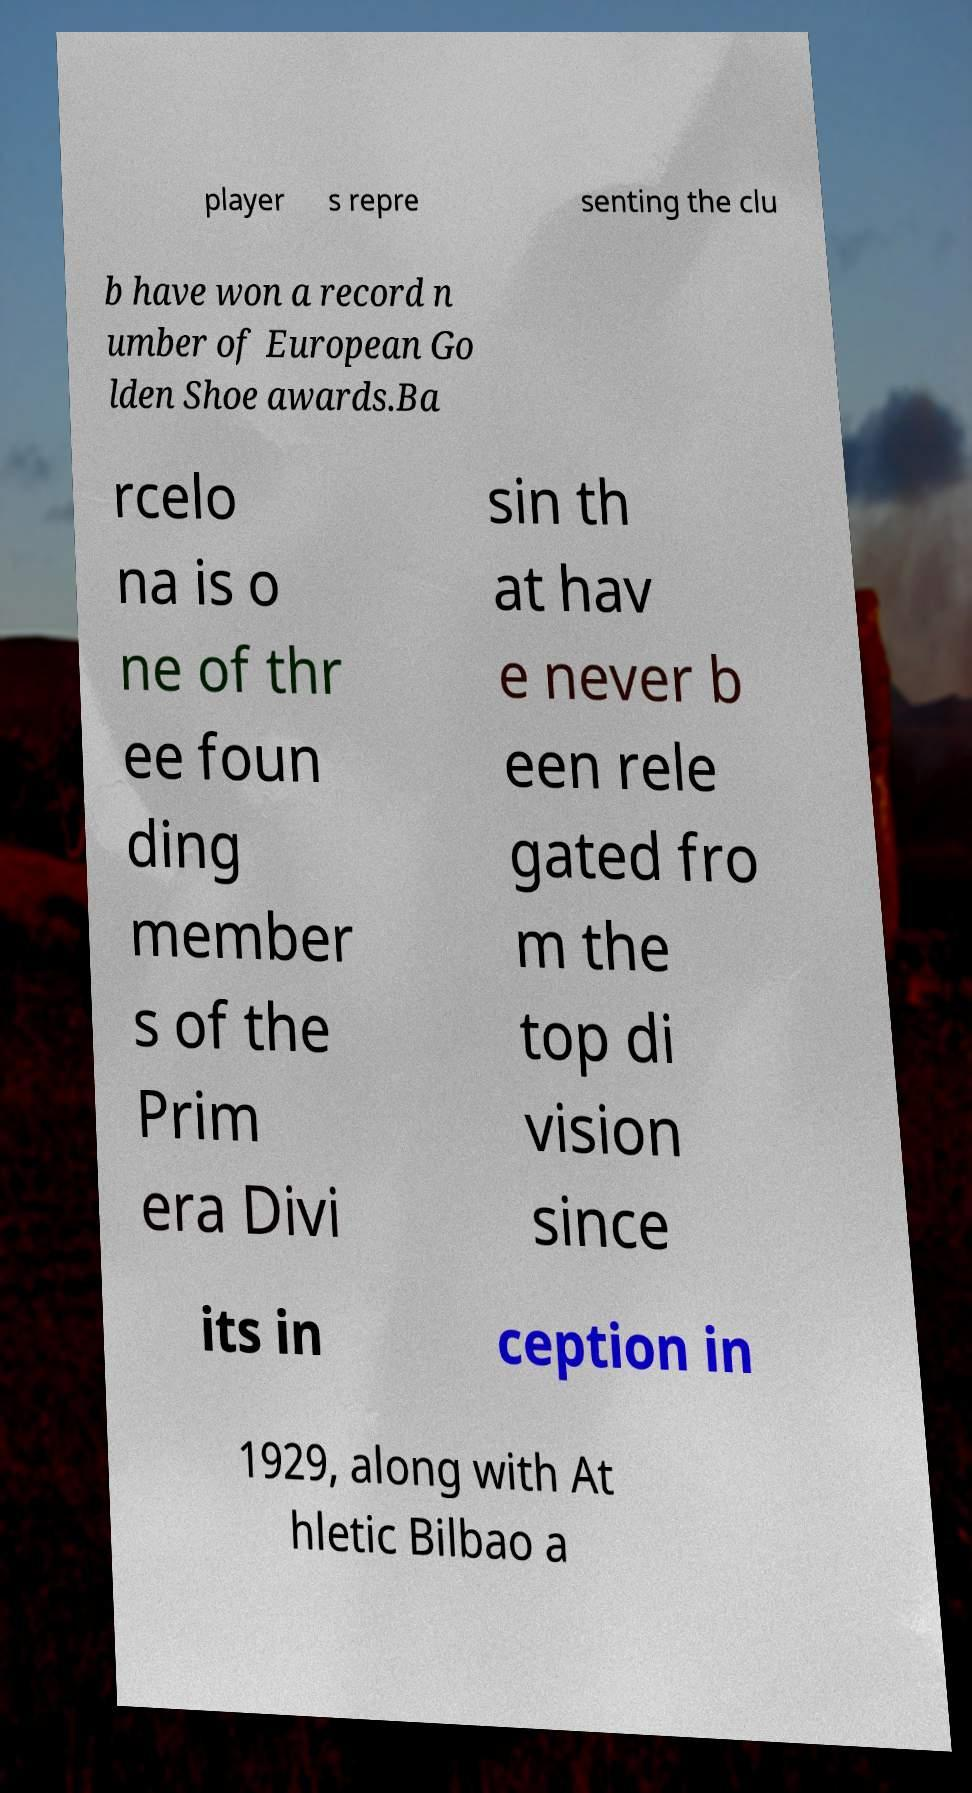For documentation purposes, I need the text within this image transcribed. Could you provide that? player s repre senting the clu b have won a record n umber of European Go lden Shoe awards.Ba rcelo na is o ne of thr ee foun ding member s of the Prim era Divi sin th at hav e never b een rele gated fro m the top di vision since its in ception in 1929, along with At hletic Bilbao a 